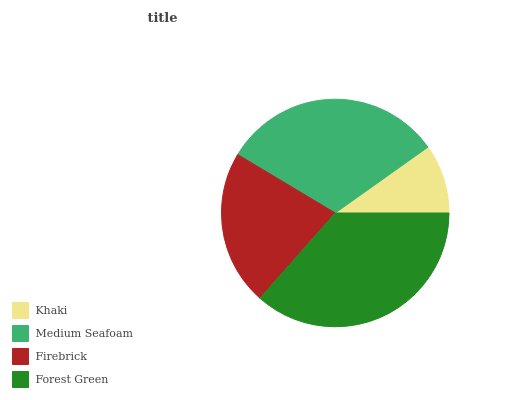Is Khaki the minimum?
Answer yes or no. Yes. Is Forest Green the maximum?
Answer yes or no. Yes. Is Medium Seafoam the minimum?
Answer yes or no. No. Is Medium Seafoam the maximum?
Answer yes or no. No. Is Medium Seafoam greater than Khaki?
Answer yes or no. Yes. Is Khaki less than Medium Seafoam?
Answer yes or no. Yes. Is Khaki greater than Medium Seafoam?
Answer yes or no. No. Is Medium Seafoam less than Khaki?
Answer yes or no. No. Is Medium Seafoam the high median?
Answer yes or no. Yes. Is Firebrick the low median?
Answer yes or no. Yes. Is Khaki the high median?
Answer yes or no. No. Is Forest Green the low median?
Answer yes or no. No. 